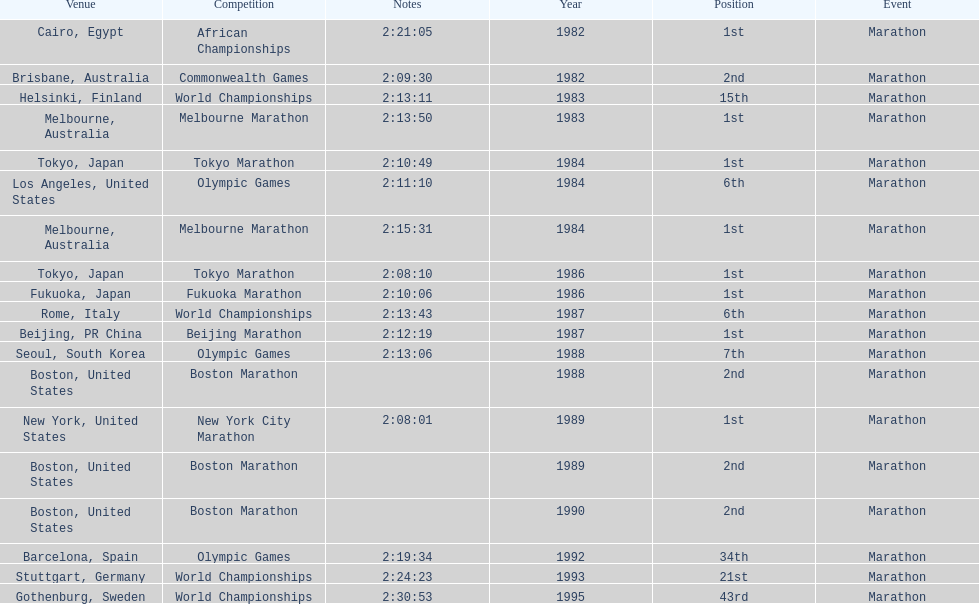In which marathon did juma ikangaa achieve his first victory? 1982 African Championships. Could you parse the entire table? {'header': ['Venue', 'Competition', 'Notes', 'Year', 'Position', 'Event'], 'rows': [['Cairo, Egypt', 'African Championships', '2:21:05', '1982', '1st', 'Marathon'], ['Brisbane, Australia', 'Commonwealth Games', '2:09:30', '1982', '2nd', 'Marathon'], ['Helsinki, Finland', 'World Championships', '2:13:11', '1983', '15th', 'Marathon'], ['Melbourne, Australia', 'Melbourne Marathon', '2:13:50', '1983', '1st', 'Marathon'], ['Tokyo, Japan', 'Tokyo Marathon', '2:10:49', '1984', '1st', 'Marathon'], ['Los Angeles, United States', 'Olympic Games', '2:11:10', '1984', '6th', 'Marathon'], ['Melbourne, Australia', 'Melbourne Marathon', '2:15:31', '1984', '1st', 'Marathon'], ['Tokyo, Japan', 'Tokyo Marathon', '2:08:10', '1986', '1st', 'Marathon'], ['Fukuoka, Japan', 'Fukuoka Marathon', '2:10:06', '1986', '1st', 'Marathon'], ['Rome, Italy', 'World Championships', '2:13:43', '1987', '6th', 'Marathon'], ['Beijing, PR China', 'Beijing Marathon', '2:12:19', '1987', '1st', 'Marathon'], ['Seoul, South Korea', 'Olympic Games', '2:13:06', '1988', '7th', 'Marathon'], ['Boston, United States', 'Boston Marathon', '', '1988', '2nd', 'Marathon'], ['New York, United States', 'New York City Marathon', '2:08:01', '1989', '1st', 'Marathon'], ['Boston, United States', 'Boston Marathon', '', '1989', '2nd', 'Marathon'], ['Boston, United States', 'Boston Marathon', '', '1990', '2nd', 'Marathon'], ['Barcelona, Spain', 'Olympic Games', '2:19:34', '1992', '34th', 'Marathon'], ['Stuttgart, Germany', 'World Championships', '2:24:23', '1993', '21st', 'Marathon'], ['Gothenburg, Sweden', 'World Championships', '2:30:53', '1995', '43rd', 'Marathon']]} 